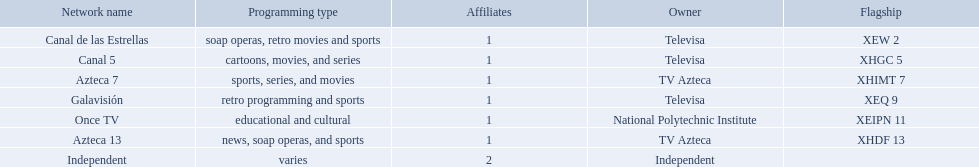What station shows cartoons? Canal 5. What station shows soap operas? Canal de las Estrellas. What station shows sports? Azteca 7. 